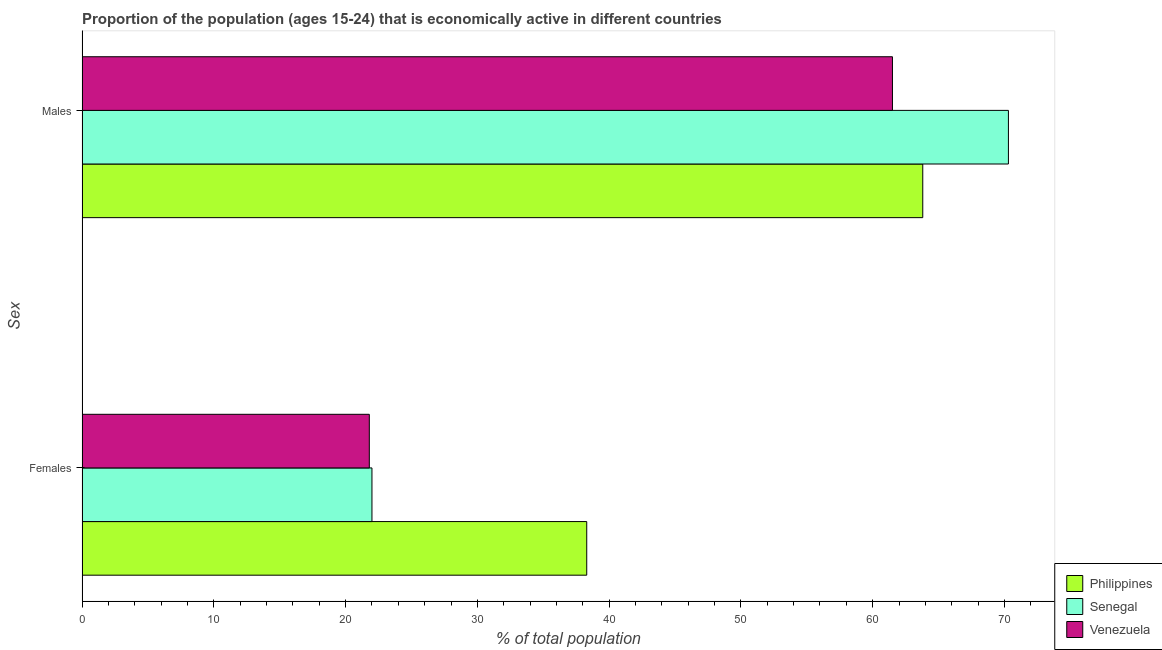How many different coloured bars are there?
Offer a very short reply. 3. How many bars are there on the 1st tick from the top?
Offer a terse response. 3. How many bars are there on the 2nd tick from the bottom?
Give a very brief answer. 3. What is the label of the 1st group of bars from the top?
Provide a succinct answer. Males. What is the percentage of economically active female population in Venezuela?
Your answer should be compact. 21.8. Across all countries, what is the maximum percentage of economically active female population?
Make the answer very short. 38.3. Across all countries, what is the minimum percentage of economically active male population?
Offer a very short reply. 61.5. In which country was the percentage of economically active female population maximum?
Your response must be concise. Philippines. In which country was the percentage of economically active male population minimum?
Your response must be concise. Venezuela. What is the total percentage of economically active female population in the graph?
Offer a very short reply. 82.1. What is the difference between the percentage of economically active female population in Philippines and that in Senegal?
Ensure brevity in your answer.  16.3. What is the difference between the percentage of economically active female population in Philippines and the percentage of economically active male population in Venezuela?
Offer a terse response. -23.2. What is the average percentage of economically active female population per country?
Provide a succinct answer. 27.37. What is the difference between the percentage of economically active female population and percentage of economically active male population in Venezuela?
Keep it short and to the point. -39.7. What is the ratio of the percentage of economically active female population in Venezuela to that in Philippines?
Your answer should be compact. 0.57. What does the 1st bar from the bottom in Females represents?
Offer a terse response. Philippines. Are all the bars in the graph horizontal?
Offer a terse response. Yes. Are the values on the major ticks of X-axis written in scientific E-notation?
Provide a succinct answer. No. How are the legend labels stacked?
Your response must be concise. Vertical. What is the title of the graph?
Provide a succinct answer. Proportion of the population (ages 15-24) that is economically active in different countries. Does "Lesotho" appear as one of the legend labels in the graph?
Give a very brief answer. No. What is the label or title of the X-axis?
Give a very brief answer. % of total population. What is the label or title of the Y-axis?
Give a very brief answer. Sex. What is the % of total population in Philippines in Females?
Your response must be concise. 38.3. What is the % of total population in Venezuela in Females?
Offer a terse response. 21.8. What is the % of total population of Philippines in Males?
Make the answer very short. 63.8. What is the % of total population in Senegal in Males?
Offer a very short reply. 70.3. What is the % of total population in Venezuela in Males?
Provide a succinct answer. 61.5. Across all Sex, what is the maximum % of total population of Philippines?
Give a very brief answer. 63.8. Across all Sex, what is the maximum % of total population in Senegal?
Your response must be concise. 70.3. Across all Sex, what is the maximum % of total population of Venezuela?
Give a very brief answer. 61.5. Across all Sex, what is the minimum % of total population of Philippines?
Offer a terse response. 38.3. Across all Sex, what is the minimum % of total population of Venezuela?
Give a very brief answer. 21.8. What is the total % of total population in Philippines in the graph?
Ensure brevity in your answer.  102.1. What is the total % of total population in Senegal in the graph?
Provide a short and direct response. 92.3. What is the total % of total population of Venezuela in the graph?
Your response must be concise. 83.3. What is the difference between the % of total population of Philippines in Females and that in Males?
Offer a terse response. -25.5. What is the difference between the % of total population in Senegal in Females and that in Males?
Provide a short and direct response. -48.3. What is the difference between the % of total population in Venezuela in Females and that in Males?
Offer a very short reply. -39.7. What is the difference between the % of total population of Philippines in Females and the % of total population of Senegal in Males?
Provide a short and direct response. -32. What is the difference between the % of total population in Philippines in Females and the % of total population in Venezuela in Males?
Give a very brief answer. -23.2. What is the difference between the % of total population of Senegal in Females and the % of total population of Venezuela in Males?
Your answer should be very brief. -39.5. What is the average % of total population of Philippines per Sex?
Give a very brief answer. 51.05. What is the average % of total population of Senegal per Sex?
Provide a succinct answer. 46.15. What is the average % of total population of Venezuela per Sex?
Keep it short and to the point. 41.65. What is the difference between the % of total population in Philippines and % of total population in Venezuela in Males?
Your answer should be very brief. 2.3. What is the difference between the % of total population in Senegal and % of total population in Venezuela in Males?
Your answer should be compact. 8.8. What is the ratio of the % of total population in Philippines in Females to that in Males?
Offer a very short reply. 0.6. What is the ratio of the % of total population in Senegal in Females to that in Males?
Provide a short and direct response. 0.31. What is the ratio of the % of total population in Venezuela in Females to that in Males?
Make the answer very short. 0.35. What is the difference between the highest and the second highest % of total population of Senegal?
Provide a succinct answer. 48.3. What is the difference between the highest and the second highest % of total population of Venezuela?
Offer a very short reply. 39.7. What is the difference between the highest and the lowest % of total population of Senegal?
Your answer should be very brief. 48.3. What is the difference between the highest and the lowest % of total population of Venezuela?
Your response must be concise. 39.7. 